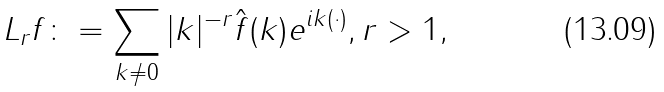<formula> <loc_0><loc_0><loc_500><loc_500>L _ { r } f \colon = \sum _ { k \neq 0 } | k | ^ { - r } \hat { f } ( k ) e ^ { i k ( \cdot ) } , r > 1 ,</formula> 